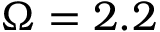Convert formula to latex. <formula><loc_0><loc_0><loc_500><loc_500>\Omega = 2 . 2</formula> 